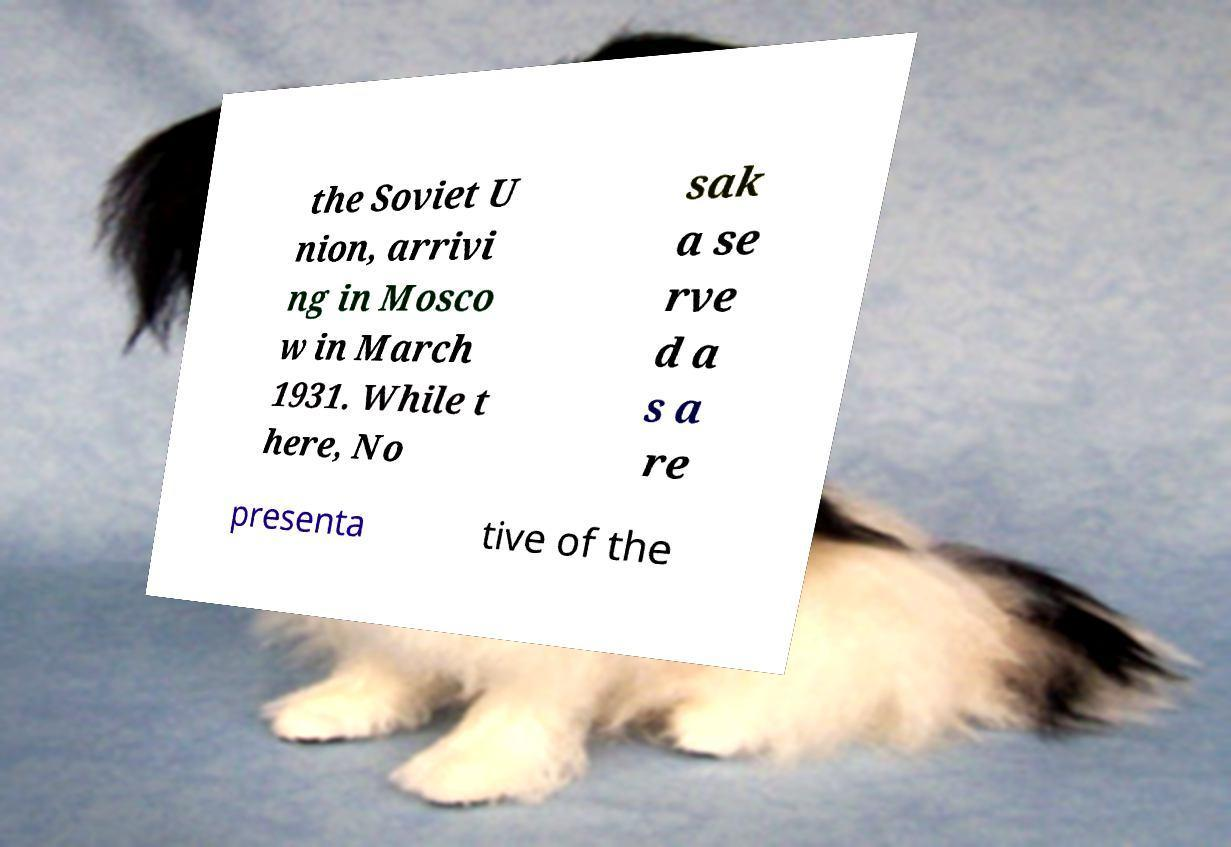Please identify and transcribe the text found in this image. the Soviet U nion, arrivi ng in Mosco w in March 1931. While t here, No sak a se rve d a s a re presenta tive of the 